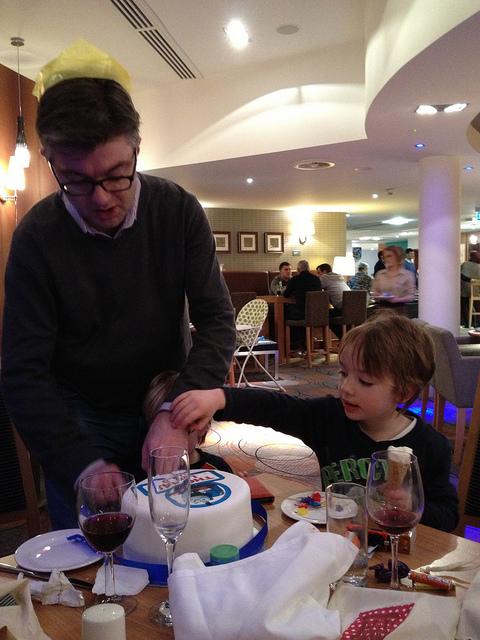Are they drinking wine at the child's party?
Give a very brief answer. Yes. Is the man wearing glasses?
Concise answer only. Yes. What is the man holding?
Short answer required. Knife. What is the man cutting?
Write a very short answer. Cake. 